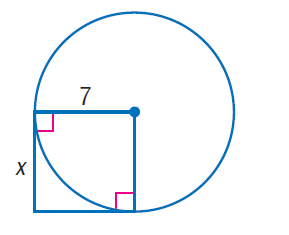Question: Find x. Assume that segments that appear to be tangent are tangent.
Choices:
A. \sqrt { 7 }
B. 7
C. 7 \sqrt { 2 }
D. 49
Answer with the letter. Answer: B 